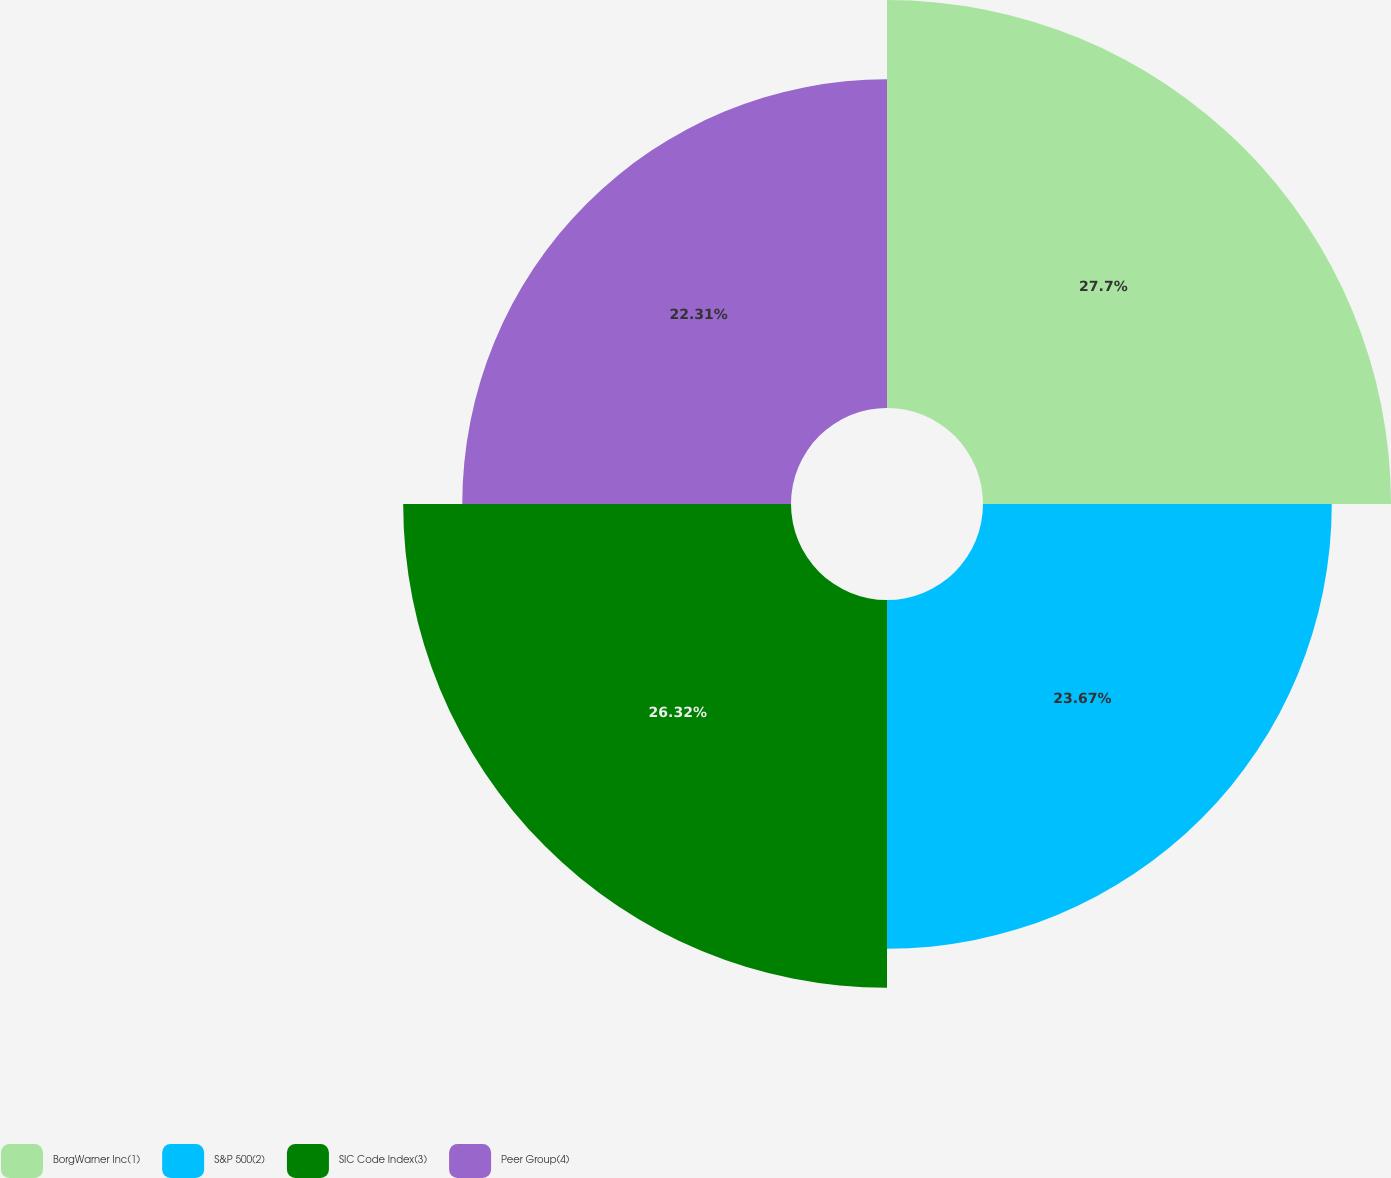Convert chart to OTSL. <chart><loc_0><loc_0><loc_500><loc_500><pie_chart><fcel>BorgWarner Inc(1)<fcel>S&P 500(2)<fcel>SIC Code Index(3)<fcel>Peer Group(4)<nl><fcel>27.69%<fcel>23.67%<fcel>26.32%<fcel>22.31%<nl></chart> 